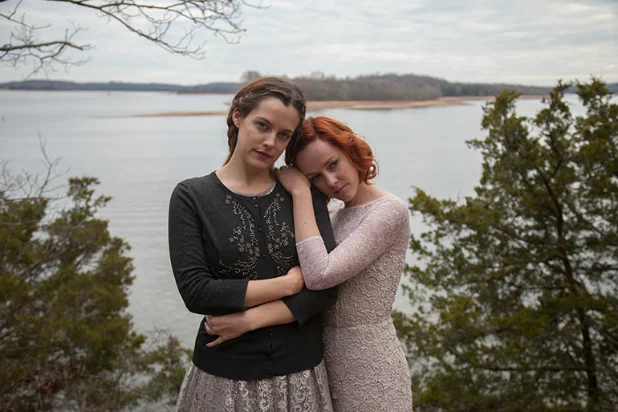Analyze the image in a comprehensive and detailed manner. The image captures two women standing closely together against a natural backdrop of a vast lake and a distant treeline, under an overcast sky. The woman on the left wears a long-sleeve black top with a delicate floral pattern near the neckline and a long skirt. She holds her own forearms, suggesting a reserved or contemplative demeanor. The woman on the right dons a light pink, long-sleeve dress with subtle textile designs, embracing the other woman in a gentle and comforting manner. Both display solemn expressions and are looking directly at the camera, adding a direct and personal touch to the viewer's experience. This setting and their attire suggest a calm yet poignant moment, surrounded by the serene beauty of a natural landscape. 